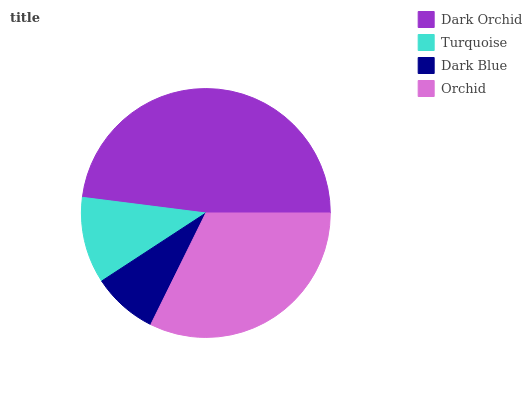Is Dark Blue the minimum?
Answer yes or no. Yes. Is Dark Orchid the maximum?
Answer yes or no. Yes. Is Turquoise the minimum?
Answer yes or no. No. Is Turquoise the maximum?
Answer yes or no. No. Is Dark Orchid greater than Turquoise?
Answer yes or no. Yes. Is Turquoise less than Dark Orchid?
Answer yes or no. Yes. Is Turquoise greater than Dark Orchid?
Answer yes or no. No. Is Dark Orchid less than Turquoise?
Answer yes or no. No. Is Orchid the high median?
Answer yes or no. Yes. Is Turquoise the low median?
Answer yes or no. Yes. Is Dark Orchid the high median?
Answer yes or no. No. Is Dark Blue the low median?
Answer yes or no. No. 